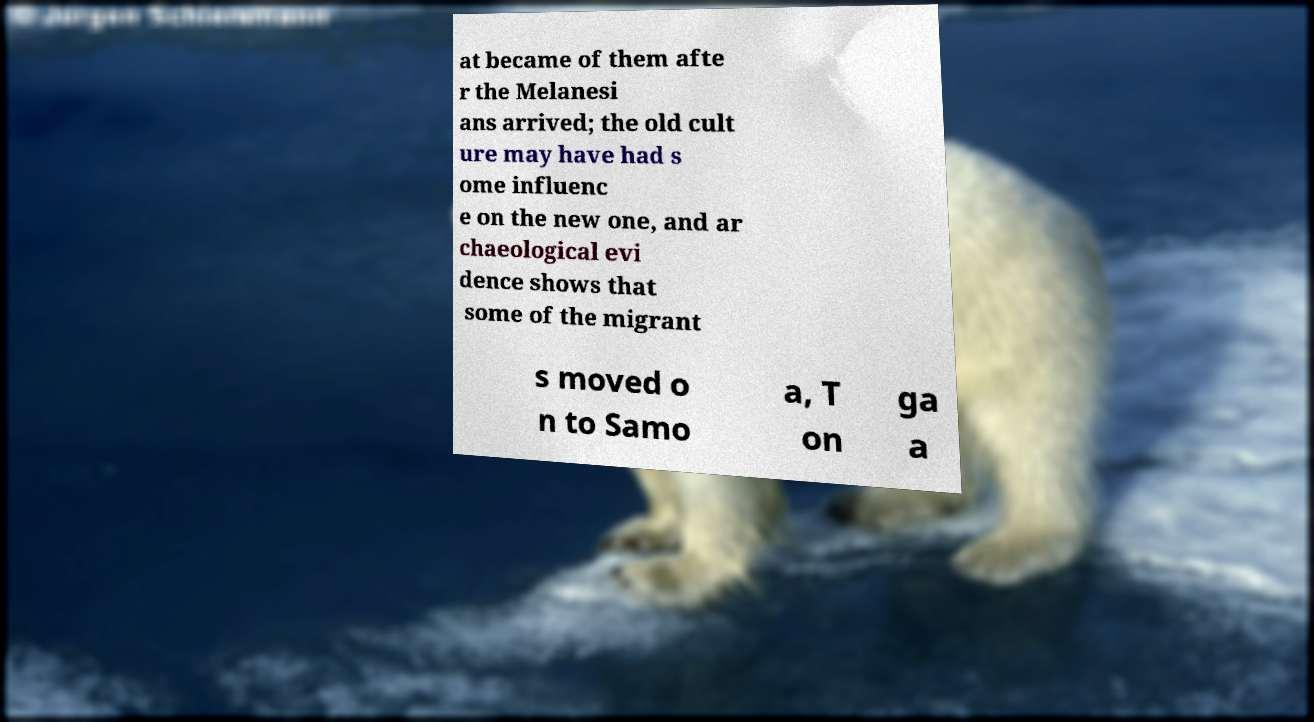There's text embedded in this image that I need extracted. Can you transcribe it verbatim? at became of them afte r the Melanesi ans arrived; the old cult ure may have had s ome influenc e on the new one, and ar chaeological evi dence shows that some of the migrant s moved o n to Samo a, T on ga a 